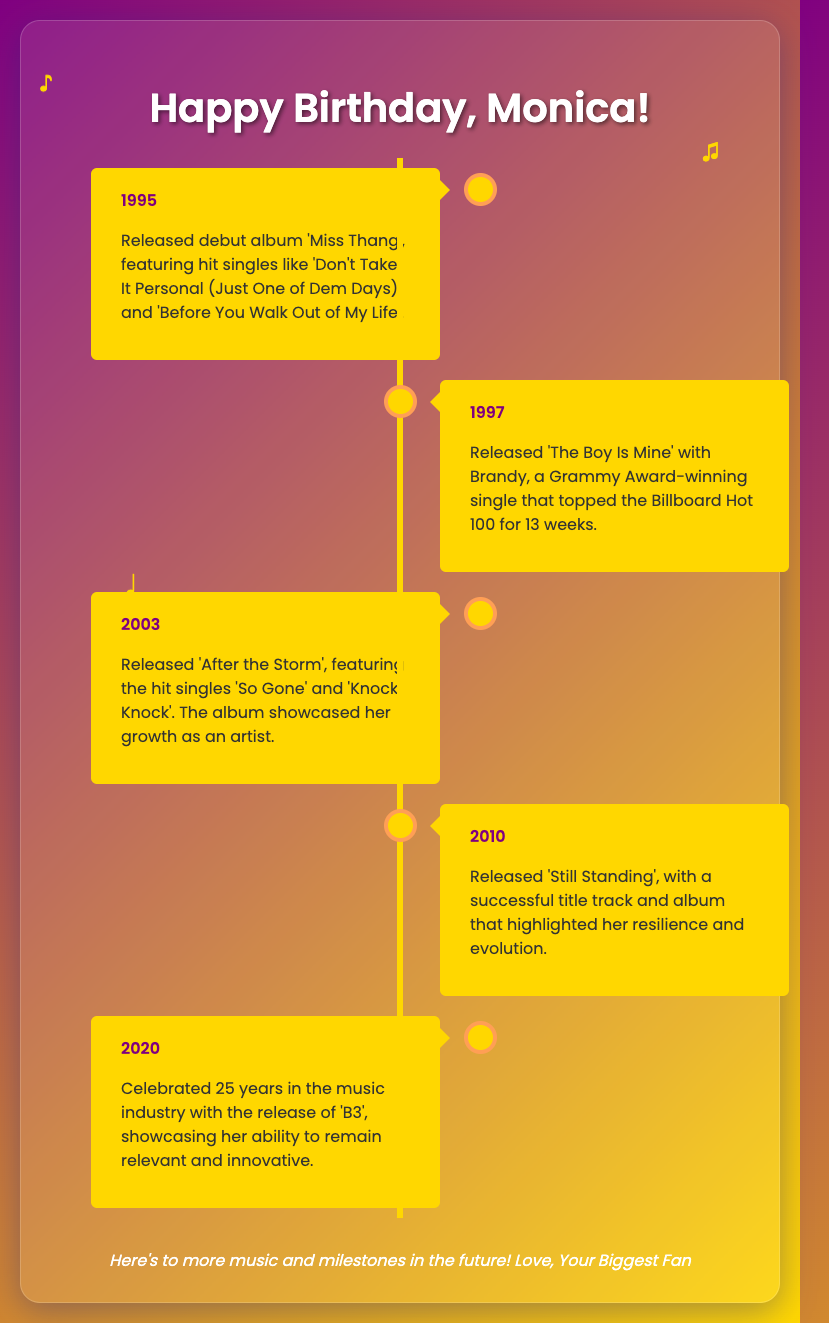What year did Monica release her debut album? Monica released her debut album 'Miss Thang' in 1995.
Answer: 1995 What is the title of the Grammy Award-winning single she released with Brandy? The single Monica released with Brandy is titled 'The Boy Is Mine'.
Answer: The Boy Is Mine How many weeks did 'The Boy Is Mine' stay at the top of the Billboard Hot 100? 'The Boy Is Mine' topped the Billboard Hot 100 for 13 weeks.
Answer: 13 weeks What was the title of Monica's album released in 2003? The title of Monica's album released in 2003 is 'After the Storm'.
Answer: After the Storm In what year did Monica celebrate 25 years in the music industry? Monica celebrated 25 years in the music industry in 2020.
Answer: 2020 What color is the timeline's central line in the card design? The central line of the timeline is colored gold.
Answer: Gold Which two terms are used to describe Monica's evolution in her 2010 album? The terms used to describe her evolution in the 2010 album are "resilience" and "evolution".
Answer: Resilience and evolution What is the overall theme of the birthday card? The overall theme of the birthday card is to celebrate Monica's milestone years and achievements.
Answer: Celebrate Monica's milestone years and achievements Who is the message at the end of the card addressed to? The message at the end of the card is addressed to "Your Biggest Fan".
Answer: Your Biggest Fan 